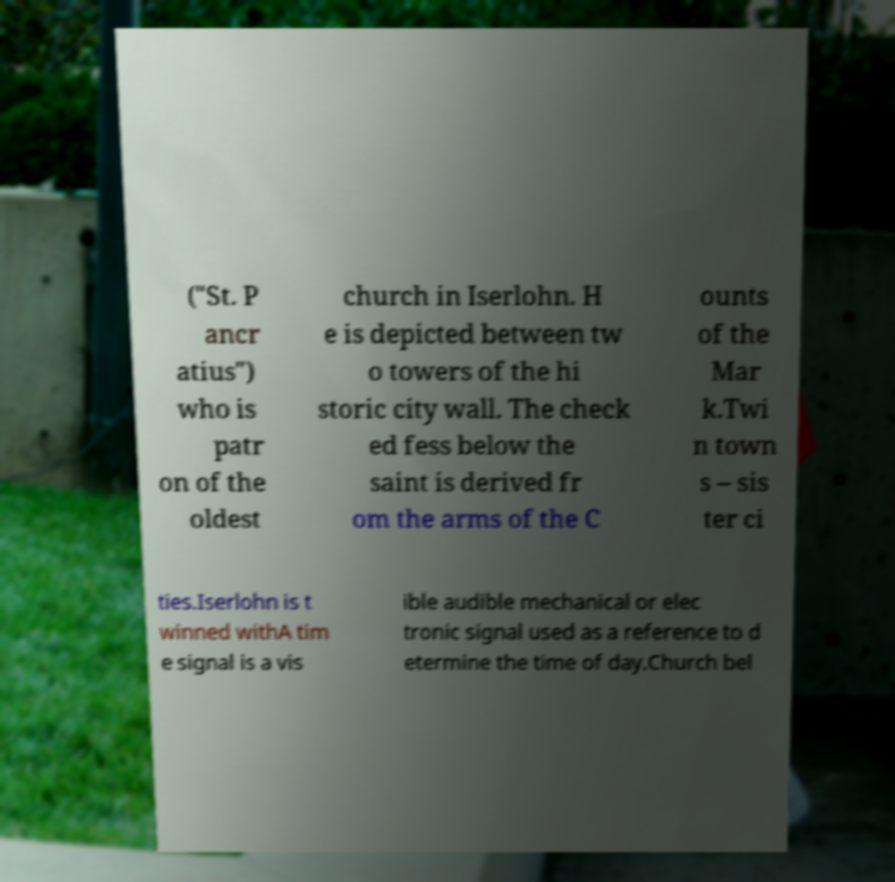What messages or text are displayed in this image? I need them in a readable, typed format. ("St. P ancr atius") who is patr on of the oldest church in Iserlohn. H e is depicted between tw o towers of the hi storic city wall. The check ed fess below the saint is derived fr om the arms of the C ounts of the Mar k.Twi n town s – sis ter ci ties.Iserlohn is t winned withA tim e signal is a vis ible audible mechanical or elec tronic signal used as a reference to d etermine the time of day.Church bel 